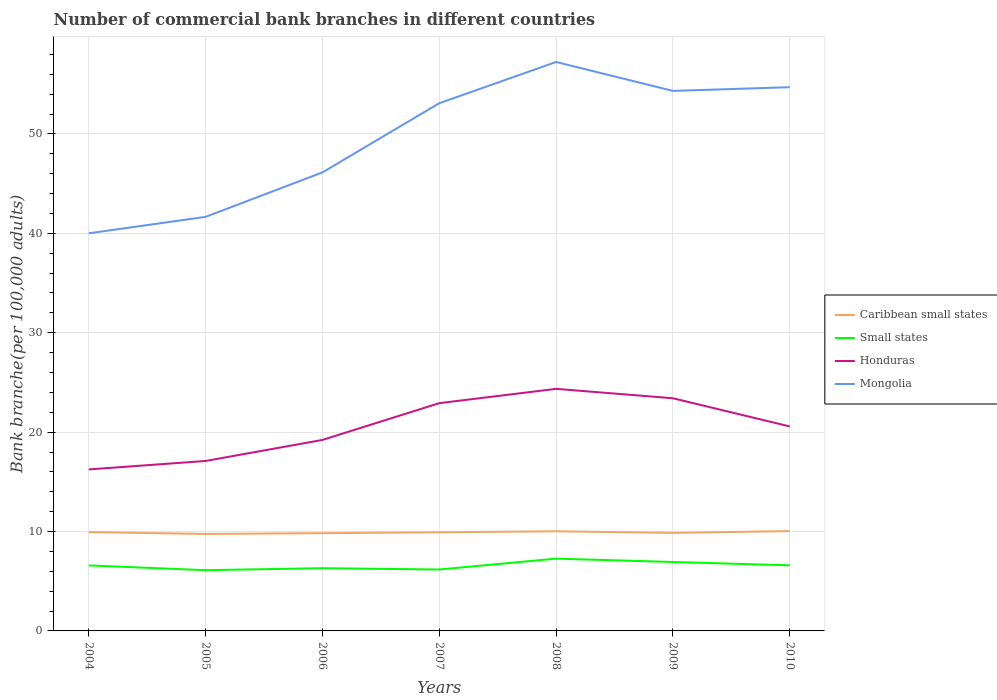How many different coloured lines are there?
Give a very brief answer. 4. Does the line corresponding to Small states intersect with the line corresponding to Caribbean small states?
Provide a short and direct response. No. Across all years, what is the maximum number of commercial bank branches in Mongolia?
Offer a very short reply. 40. What is the total number of commercial bank branches in Small states in the graph?
Your answer should be compact. 0.34. What is the difference between the highest and the second highest number of commercial bank branches in Honduras?
Give a very brief answer. 8.11. How many lines are there?
Keep it short and to the point. 4. Are the values on the major ticks of Y-axis written in scientific E-notation?
Offer a terse response. No. Does the graph contain grids?
Your response must be concise. Yes. Where does the legend appear in the graph?
Provide a short and direct response. Center right. What is the title of the graph?
Ensure brevity in your answer.  Number of commercial bank branches in different countries. What is the label or title of the Y-axis?
Make the answer very short. Bank branche(per 100,0 adults). What is the Bank branche(per 100,000 adults) in Caribbean small states in 2004?
Your response must be concise. 9.95. What is the Bank branche(per 100,000 adults) of Small states in 2004?
Your answer should be compact. 6.59. What is the Bank branche(per 100,000 adults) of Honduras in 2004?
Provide a short and direct response. 16.25. What is the Bank branche(per 100,000 adults) in Mongolia in 2004?
Provide a succinct answer. 40. What is the Bank branche(per 100,000 adults) in Caribbean small states in 2005?
Give a very brief answer. 9.76. What is the Bank branche(per 100,000 adults) in Small states in 2005?
Your answer should be very brief. 6.11. What is the Bank branche(per 100,000 adults) of Honduras in 2005?
Make the answer very short. 17.1. What is the Bank branche(per 100,000 adults) in Mongolia in 2005?
Give a very brief answer. 41.66. What is the Bank branche(per 100,000 adults) of Caribbean small states in 2006?
Make the answer very short. 9.84. What is the Bank branche(per 100,000 adults) in Small states in 2006?
Offer a very short reply. 6.31. What is the Bank branche(per 100,000 adults) in Honduras in 2006?
Your answer should be compact. 19.22. What is the Bank branche(per 100,000 adults) in Mongolia in 2006?
Offer a terse response. 46.13. What is the Bank branche(per 100,000 adults) in Caribbean small states in 2007?
Offer a terse response. 9.92. What is the Bank branche(per 100,000 adults) in Small states in 2007?
Offer a very short reply. 6.18. What is the Bank branche(per 100,000 adults) in Honduras in 2007?
Your answer should be very brief. 22.92. What is the Bank branche(per 100,000 adults) of Mongolia in 2007?
Provide a short and direct response. 53.09. What is the Bank branche(per 100,000 adults) in Caribbean small states in 2008?
Give a very brief answer. 10.02. What is the Bank branche(per 100,000 adults) in Small states in 2008?
Offer a terse response. 7.27. What is the Bank branche(per 100,000 adults) in Honduras in 2008?
Make the answer very short. 24.36. What is the Bank branche(per 100,000 adults) of Mongolia in 2008?
Ensure brevity in your answer.  57.24. What is the Bank branche(per 100,000 adults) of Caribbean small states in 2009?
Your answer should be compact. 9.86. What is the Bank branche(per 100,000 adults) of Small states in 2009?
Ensure brevity in your answer.  6.94. What is the Bank branche(per 100,000 adults) of Honduras in 2009?
Provide a short and direct response. 23.41. What is the Bank branche(per 100,000 adults) in Mongolia in 2009?
Provide a succinct answer. 54.33. What is the Bank branche(per 100,000 adults) of Caribbean small states in 2010?
Give a very brief answer. 10.04. What is the Bank branche(per 100,000 adults) of Small states in 2010?
Offer a very short reply. 6.6. What is the Bank branche(per 100,000 adults) of Honduras in 2010?
Keep it short and to the point. 20.57. What is the Bank branche(per 100,000 adults) of Mongolia in 2010?
Make the answer very short. 54.7. Across all years, what is the maximum Bank branche(per 100,000 adults) in Caribbean small states?
Keep it short and to the point. 10.04. Across all years, what is the maximum Bank branche(per 100,000 adults) of Small states?
Provide a short and direct response. 7.27. Across all years, what is the maximum Bank branche(per 100,000 adults) in Honduras?
Make the answer very short. 24.36. Across all years, what is the maximum Bank branche(per 100,000 adults) of Mongolia?
Make the answer very short. 57.24. Across all years, what is the minimum Bank branche(per 100,000 adults) in Caribbean small states?
Give a very brief answer. 9.76. Across all years, what is the minimum Bank branche(per 100,000 adults) of Small states?
Keep it short and to the point. 6.11. Across all years, what is the minimum Bank branche(per 100,000 adults) of Honduras?
Offer a very short reply. 16.25. Across all years, what is the minimum Bank branche(per 100,000 adults) of Mongolia?
Offer a very short reply. 40. What is the total Bank branche(per 100,000 adults) in Caribbean small states in the graph?
Make the answer very short. 69.39. What is the total Bank branche(per 100,000 adults) in Small states in the graph?
Your response must be concise. 46. What is the total Bank branche(per 100,000 adults) of Honduras in the graph?
Offer a very short reply. 143.81. What is the total Bank branche(per 100,000 adults) of Mongolia in the graph?
Your answer should be compact. 347.16. What is the difference between the Bank branche(per 100,000 adults) of Caribbean small states in 2004 and that in 2005?
Give a very brief answer. 0.19. What is the difference between the Bank branche(per 100,000 adults) in Small states in 2004 and that in 2005?
Provide a succinct answer. 0.48. What is the difference between the Bank branche(per 100,000 adults) in Honduras in 2004 and that in 2005?
Provide a succinct answer. -0.85. What is the difference between the Bank branche(per 100,000 adults) in Mongolia in 2004 and that in 2005?
Offer a terse response. -1.65. What is the difference between the Bank branche(per 100,000 adults) in Caribbean small states in 2004 and that in 2006?
Provide a short and direct response. 0.11. What is the difference between the Bank branche(per 100,000 adults) in Small states in 2004 and that in 2006?
Ensure brevity in your answer.  0.28. What is the difference between the Bank branche(per 100,000 adults) in Honduras in 2004 and that in 2006?
Your response must be concise. -2.97. What is the difference between the Bank branche(per 100,000 adults) of Mongolia in 2004 and that in 2006?
Ensure brevity in your answer.  -6.13. What is the difference between the Bank branche(per 100,000 adults) of Caribbean small states in 2004 and that in 2007?
Ensure brevity in your answer.  0.02. What is the difference between the Bank branche(per 100,000 adults) in Small states in 2004 and that in 2007?
Make the answer very short. 0.41. What is the difference between the Bank branche(per 100,000 adults) of Honduras in 2004 and that in 2007?
Offer a very short reply. -6.67. What is the difference between the Bank branche(per 100,000 adults) in Mongolia in 2004 and that in 2007?
Provide a short and direct response. -13.09. What is the difference between the Bank branche(per 100,000 adults) of Caribbean small states in 2004 and that in 2008?
Your response must be concise. -0.08. What is the difference between the Bank branche(per 100,000 adults) of Small states in 2004 and that in 2008?
Offer a terse response. -0.68. What is the difference between the Bank branche(per 100,000 adults) of Honduras in 2004 and that in 2008?
Keep it short and to the point. -8.11. What is the difference between the Bank branche(per 100,000 adults) of Mongolia in 2004 and that in 2008?
Your answer should be very brief. -17.24. What is the difference between the Bank branche(per 100,000 adults) of Caribbean small states in 2004 and that in 2009?
Your answer should be compact. 0.08. What is the difference between the Bank branche(per 100,000 adults) in Small states in 2004 and that in 2009?
Make the answer very short. -0.35. What is the difference between the Bank branche(per 100,000 adults) in Honduras in 2004 and that in 2009?
Provide a succinct answer. -7.16. What is the difference between the Bank branche(per 100,000 adults) of Mongolia in 2004 and that in 2009?
Your answer should be compact. -14.33. What is the difference between the Bank branche(per 100,000 adults) of Caribbean small states in 2004 and that in 2010?
Keep it short and to the point. -0.1. What is the difference between the Bank branche(per 100,000 adults) of Small states in 2004 and that in 2010?
Your answer should be very brief. -0.01. What is the difference between the Bank branche(per 100,000 adults) of Honduras in 2004 and that in 2010?
Offer a very short reply. -4.33. What is the difference between the Bank branche(per 100,000 adults) of Mongolia in 2004 and that in 2010?
Make the answer very short. -14.7. What is the difference between the Bank branche(per 100,000 adults) in Caribbean small states in 2005 and that in 2006?
Make the answer very short. -0.08. What is the difference between the Bank branche(per 100,000 adults) of Small states in 2005 and that in 2006?
Offer a very short reply. -0.2. What is the difference between the Bank branche(per 100,000 adults) of Honduras in 2005 and that in 2006?
Make the answer very short. -2.12. What is the difference between the Bank branche(per 100,000 adults) of Mongolia in 2005 and that in 2006?
Your answer should be very brief. -4.48. What is the difference between the Bank branche(per 100,000 adults) in Caribbean small states in 2005 and that in 2007?
Ensure brevity in your answer.  -0.16. What is the difference between the Bank branche(per 100,000 adults) in Small states in 2005 and that in 2007?
Provide a succinct answer. -0.07. What is the difference between the Bank branche(per 100,000 adults) in Honduras in 2005 and that in 2007?
Give a very brief answer. -5.82. What is the difference between the Bank branche(per 100,000 adults) in Mongolia in 2005 and that in 2007?
Your response must be concise. -11.43. What is the difference between the Bank branche(per 100,000 adults) in Caribbean small states in 2005 and that in 2008?
Ensure brevity in your answer.  -0.27. What is the difference between the Bank branche(per 100,000 adults) in Small states in 2005 and that in 2008?
Provide a short and direct response. -1.16. What is the difference between the Bank branche(per 100,000 adults) in Honduras in 2005 and that in 2008?
Ensure brevity in your answer.  -7.26. What is the difference between the Bank branche(per 100,000 adults) in Mongolia in 2005 and that in 2008?
Give a very brief answer. -15.58. What is the difference between the Bank branche(per 100,000 adults) of Caribbean small states in 2005 and that in 2009?
Offer a very short reply. -0.11. What is the difference between the Bank branche(per 100,000 adults) in Small states in 2005 and that in 2009?
Offer a terse response. -0.83. What is the difference between the Bank branche(per 100,000 adults) in Honduras in 2005 and that in 2009?
Ensure brevity in your answer.  -6.31. What is the difference between the Bank branche(per 100,000 adults) of Mongolia in 2005 and that in 2009?
Keep it short and to the point. -12.67. What is the difference between the Bank branche(per 100,000 adults) of Caribbean small states in 2005 and that in 2010?
Provide a short and direct response. -0.29. What is the difference between the Bank branche(per 100,000 adults) in Small states in 2005 and that in 2010?
Make the answer very short. -0.49. What is the difference between the Bank branche(per 100,000 adults) of Honduras in 2005 and that in 2010?
Ensure brevity in your answer.  -3.47. What is the difference between the Bank branche(per 100,000 adults) of Mongolia in 2005 and that in 2010?
Your answer should be compact. -13.05. What is the difference between the Bank branche(per 100,000 adults) in Caribbean small states in 2006 and that in 2007?
Make the answer very short. -0.09. What is the difference between the Bank branche(per 100,000 adults) of Small states in 2006 and that in 2007?
Offer a terse response. 0.14. What is the difference between the Bank branche(per 100,000 adults) of Honduras in 2006 and that in 2007?
Your answer should be compact. -3.7. What is the difference between the Bank branche(per 100,000 adults) in Mongolia in 2006 and that in 2007?
Your answer should be very brief. -6.96. What is the difference between the Bank branche(per 100,000 adults) of Caribbean small states in 2006 and that in 2008?
Your response must be concise. -0.19. What is the difference between the Bank branche(per 100,000 adults) in Small states in 2006 and that in 2008?
Ensure brevity in your answer.  -0.96. What is the difference between the Bank branche(per 100,000 adults) of Honduras in 2006 and that in 2008?
Offer a terse response. -5.14. What is the difference between the Bank branche(per 100,000 adults) in Mongolia in 2006 and that in 2008?
Offer a terse response. -11.11. What is the difference between the Bank branche(per 100,000 adults) in Caribbean small states in 2006 and that in 2009?
Your response must be concise. -0.03. What is the difference between the Bank branche(per 100,000 adults) in Small states in 2006 and that in 2009?
Give a very brief answer. -0.62. What is the difference between the Bank branche(per 100,000 adults) of Honduras in 2006 and that in 2009?
Make the answer very short. -4.19. What is the difference between the Bank branche(per 100,000 adults) in Mongolia in 2006 and that in 2009?
Your answer should be very brief. -8.2. What is the difference between the Bank branche(per 100,000 adults) in Caribbean small states in 2006 and that in 2010?
Offer a terse response. -0.21. What is the difference between the Bank branche(per 100,000 adults) in Small states in 2006 and that in 2010?
Offer a terse response. -0.29. What is the difference between the Bank branche(per 100,000 adults) of Honduras in 2006 and that in 2010?
Your answer should be compact. -1.36. What is the difference between the Bank branche(per 100,000 adults) in Mongolia in 2006 and that in 2010?
Make the answer very short. -8.57. What is the difference between the Bank branche(per 100,000 adults) in Caribbean small states in 2007 and that in 2008?
Your answer should be very brief. -0.1. What is the difference between the Bank branche(per 100,000 adults) in Small states in 2007 and that in 2008?
Offer a terse response. -1.1. What is the difference between the Bank branche(per 100,000 adults) in Honduras in 2007 and that in 2008?
Ensure brevity in your answer.  -1.44. What is the difference between the Bank branche(per 100,000 adults) in Mongolia in 2007 and that in 2008?
Provide a short and direct response. -4.15. What is the difference between the Bank branche(per 100,000 adults) of Caribbean small states in 2007 and that in 2009?
Provide a short and direct response. 0.06. What is the difference between the Bank branche(per 100,000 adults) in Small states in 2007 and that in 2009?
Your answer should be compact. -0.76. What is the difference between the Bank branche(per 100,000 adults) in Honduras in 2007 and that in 2009?
Keep it short and to the point. -0.49. What is the difference between the Bank branche(per 100,000 adults) in Mongolia in 2007 and that in 2009?
Offer a very short reply. -1.24. What is the difference between the Bank branche(per 100,000 adults) in Caribbean small states in 2007 and that in 2010?
Your answer should be compact. -0.12. What is the difference between the Bank branche(per 100,000 adults) in Small states in 2007 and that in 2010?
Your answer should be very brief. -0.42. What is the difference between the Bank branche(per 100,000 adults) in Honduras in 2007 and that in 2010?
Your response must be concise. 2.34. What is the difference between the Bank branche(per 100,000 adults) in Mongolia in 2007 and that in 2010?
Keep it short and to the point. -1.61. What is the difference between the Bank branche(per 100,000 adults) of Caribbean small states in 2008 and that in 2009?
Your response must be concise. 0.16. What is the difference between the Bank branche(per 100,000 adults) of Small states in 2008 and that in 2009?
Your response must be concise. 0.34. What is the difference between the Bank branche(per 100,000 adults) in Honduras in 2008 and that in 2009?
Give a very brief answer. 0.95. What is the difference between the Bank branche(per 100,000 adults) in Mongolia in 2008 and that in 2009?
Ensure brevity in your answer.  2.91. What is the difference between the Bank branche(per 100,000 adults) of Caribbean small states in 2008 and that in 2010?
Give a very brief answer. -0.02. What is the difference between the Bank branche(per 100,000 adults) in Small states in 2008 and that in 2010?
Your answer should be very brief. 0.67. What is the difference between the Bank branche(per 100,000 adults) of Honduras in 2008 and that in 2010?
Your response must be concise. 3.78. What is the difference between the Bank branche(per 100,000 adults) of Mongolia in 2008 and that in 2010?
Your answer should be very brief. 2.54. What is the difference between the Bank branche(per 100,000 adults) in Caribbean small states in 2009 and that in 2010?
Ensure brevity in your answer.  -0.18. What is the difference between the Bank branche(per 100,000 adults) in Small states in 2009 and that in 2010?
Offer a terse response. 0.34. What is the difference between the Bank branche(per 100,000 adults) of Honduras in 2009 and that in 2010?
Make the answer very short. 2.83. What is the difference between the Bank branche(per 100,000 adults) in Mongolia in 2009 and that in 2010?
Your response must be concise. -0.37. What is the difference between the Bank branche(per 100,000 adults) of Caribbean small states in 2004 and the Bank branche(per 100,000 adults) of Small states in 2005?
Offer a very short reply. 3.84. What is the difference between the Bank branche(per 100,000 adults) of Caribbean small states in 2004 and the Bank branche(per 100,000 adults) of Honduras in 2005?
Give a very brief answer. -7.15. What is the difference between the Bank branche(per 100,000 adults) of Caribbean small states in 2004 and the Bank branche(per 100,000 adults) of Mongolia in 2005?
Offer a very short reply. -31.71. What is the difference between the Bank branche(per 100,000 adults) in Small states in 2004 and the Bank branche(per 100,000 adults) in Honduras in 2005?
Offer a very short reply. -10.51. What is the difference between the Bank branche(per 100,000 adults) in Small states in 2004 and the Bank branche(per 100,000 adults) in Mongolia in 2005?
Give a very brief answer. -35.07. What is the difference between the Bank branche(per 100,000 adults) in Honduras in 2004 and the Bank branche(per 100,000 adults) in Mongolia in 2005?
Make the answer very short. -25.41. What is the difference between the Bank branche(per 100,000 adults) of Caribbean small states in 2004 and the Bank branche(per 100,000 adults) of Small states in 2006?
Give a very brief answer. 3.63. What is the difference between the Bank branche(per 100,000 adults) of Caribbean small states in 2004 and the Bank branche(per 100,000 adults) of Honduras in 2006?
Make the answer very short. -9.27. What is the difference between the Bank branche(per 100,000 adults) in Caribbean small states in 2004 and the Bank branche(per 100,000 adults) in Mongolia in 2006?
Your response must be concise. -36.19. What is the difference between the Bank branche(per 100,000 adults) in Small states in 2004 and the Bank branche(per 100,000 adults) in Honduras in 2006?
Provide a succinct answer. -12.63. What is the difference between the Bank branche(per 100,000 adults) of Small states in 2004 and the Bank branche(per 100,000 adults) of Mongolia in 2006?
Provide a succinct answer. -39.54. What is the difference between the Bank branche(per 100,000 adults) in Honduras in 2004 and the Bank branche(per 100,000 adults) in Mongolia in 2006?
Provide a succinct answer. -29.89. What is the difference between the Bank branche(per 100,000 adults) of Caribbean small states in 2004 and the Bank branche(per 100,000 adults) of Small states in 2007?
Your response must be concise. 3.77. What is the difference between the Bank branche(per 100,000 adults) in Caribbean small states in 2004 and the Bank branche(per 100,000 adults) in Honduras in 2007?
Keep it short and to the point. -12.97. What is the difference between the Bank branche(per 100,000 adults) in Caribbean small states in 2004 and the Bank branche(per 100,000 adults) in Mongolia in 2007?
Offer a terse response. -43.15. What is the difference between the Bank branche(per 100,000 adults) in Small states in 2004 and the Bank branche(per 100,000 adults) in Honduras in 2007?
Offer a terse response. -16.33. What is the difference between the Bank branche(per 100,000 adults) in Small states in 2004 and the Bank branche(per 100,000 adults) in Mongolia in 2007?
Give a very brief answer. -46.5. What is the difference between the Bank branche(per 100,000 adults) of Honduras in 2004 and the Bank branche(per 100,000 adults) of Mongolia in 2007?
Your answer should be compact. -36.85. What is the difference between the Bank branche(per 100,000 adults) of Caribbean small states in 2004 and the Bank branche(per 100,000 adults) of Small states in 2008?
Make the answer very short. 2.67. What is the difference between the Bank branche(per 100,000 adults) of Caribbean small states in 2004 and the Bank branche(per 100,000 adults) of Honduras in 2008?
Offer a very short reply. -14.41. What is the difference between the Bank branche(per 100,000 adults) in Caribbean small states in 2004 and the Bank branche(per 100,000 adults) in Mongolia in 2008?
Provide a succinct answer. -47.29. What is the difference between the Bank branche(per 100,000 adults) in Small states in 2004 and the Bank branche(per 100,000 adults) in Honduras in 2008?
Offer a very short reply. -17.77. What is the difference between the Bank branche(per 100,000 adults) in Small states in 2004 and the Bank branche(per 100,000 adults) in Mongolia in 2008?
Your response must be concise. -50.65. What is the difference between the Bank branche(per 100,000 adults) in Honduras in 2004 and the Bank branche(per 100,000 adults) in Mongolia in 2008?
Provide a succinct answer. -40.99. What is the difference between the Bank branche(per 100,000 adults) of Caribbean small states in 2004 and the Bank branche(per 100,000 adults) of Small states in 2009?
Your response must be concise. 3.01. What is the difference between the Bank branche(per 100,000 adults) of Caribbean small states in 2004 and the Bank branche(per 100,000 adults) of Honduras in 2009?
Provide a short and direct response. -13.46. What is the difference between the Bank branche(per 100,000 adults) of Caribbean small states in 2004 and the Bank branche(per 100,000 adults) of Mongolia in 2009?
Your answer should be very brief. -44.38. What is the difference between the Bank branche(per 100,000 adults) of Small states in 2004 and the Bank branche(per 100,000 adults) of Honduras in 2009?
Provide a succinct answer. -16.82. What is the difference between the Bank branche(per 100,000 adults) of Small states in 2004 and the Bank branche(per 100,000 adults) of Mongolia in 2009?
Ensure brevity in your answer.  -47.74. What is the difference between the Bank branche(per 100,000 adults) in Honduras in 2004 and the Bank branche(per 100,000 adults) in Mongolia in 2009?
Provide a short and direct response. -38.08. What is the difference between the Bank branche(per 100,000 adults) in Caribbean small states in 2004 and the Bank branche(per 100,000 adults) in Small states in 2010?
Your answer should be compact. 3.35. What is the difference between the Bank branche(per 100,000 adults) of Caribbean small states in 2004 and the Bank branche(per 100,000 adults) of Honduras in 2010?
Provide a short and direct response. -10.63. What is the difference between the Bank branche(per 100,000 adults) in Caribbean small states in 2004 and the Bank branche(per 100,000 adults) in Mongolia in 2010?
Offer a terse response. -44.76. What is the difference between the Bank branche(per 100,000 adults) of Small states in 2004 and the Bank branche(per 100,000 adults) of Honduras in 2010?
Provide a short and direct response. -13.98. What is the difference between the Bank branche(per 100,000 adults) of Small states in 2004 and the Bank branche(per 100,000 adults) of Mongolia in 2010?
Make the answer very short. -48.11. What is the difference between the Bank branche(per 100,000 adults) of Honduras in 2004 and the Bank branche(per 100,000 adults) of Mongolia in 2010?
Make the answer very short. -38.46. What is the difference between the Bank branche(per 100,000 adults) in Caribbean small states in 2005 and the Bank branche(per 100,000 adults) in Small states in 2006?
Offer a terse response. 3.45. What is the difference between the Bank branche(per 100,000 adults) of Caribbean small states in 2005 and the Bank branche(per 100,000 adults) of Honduras in 2006?
Your answer should be very brief. -9.46. What is the difference between the Bank branche(per 100,000 adults) in Caribbean small states in 2005 and the Bank branche(per 100,000 adults) in Mongolia in 2006?
Provide a succinct answer. -36.38. What is the difference between the Bank branche(per 100,000 adults) in Small states in 2005 and the Bank branche(per 100,000 adults) in Honduras in 2006?
Keep it short and to the point. -13.11. What is the difference between the Bank branche(per 100,000 adults) in Small states in 2005 and the Bank branche(per 100,000 adults) in Mongolia in 2006?
Provide a succinct answer. -40.02. What is the difference between the Bank branche(per 100,000 adults) in Honduras in 2005 and the Bank branche(per 100,000 adults) in Mongolia in 2006?
Your answer should be very brief. -29.03. What is the difference between the Bank branche(per 100,000 adults) of Caribbean small states in 2005 and the Bank branche(per 100,000 adults) of Small states in 2007?
Offer a terse response. 3.58. What is the difference between the Bank branche(per 100,000 adults) in Caribbean small states in 2005 and the Bank branche(per 100,000 adults) in Honduras in 2007?
Your answer should be very brief. -13.16. What is the difference between the Bank branche(per 100,000 adults) in Caribbean small states in 2005 and the Bank branche(per 100,000 adults) in Mongolia in 2007?
Keep it short and to the point. -43.33. What is the difference between the Bank branche(per 100,000 adults) of Small states in 2005 and the Bank branche(per 100,000 adults) of Honduras in 2007?
Ensure brevity in your answer.  -16.81. What is the difference between the Bank branche(per 100,000 adults) in Small states in 2005 and the Bank branche(per 100,000 adults) in Mongolia in 2007?
Offer a terse response. -46.98. What is the difference between the Bank branche(per 100,000 adults) of Honduras in 2005 and the Bank branche(per 100,000 adults) of Mongolia in 2007?
Keep it short and to the point. -35.99. What is the difference between the Bank branche(per 100,000 adults) in Caribbean small states in 2005 and the Bank branche(per 100,000 adults) in Small states in 2008?
Keep it short and to the point. 2.49. What is the difference between the Bank branche(per 100,000 adults) in Caribbean small states in 2005 and the Bank branche(per 100,000 adults) in Honduras in 2008?
Keep it short and to the point. -14.6. What is the difference between the Bank branche(per 100,000 adults) of Caribbean small states in 2005 and the Bank branche(per 100,000 adults) of Mongolia in 2008?
Make the answer very short. -47.48. What is the difference between the Bank branche(per 100,000 adults) in Small states in 2005 and the Bank branche(per 100,000 adults) in Honduras in 2008?
Offer a very short reply. -18.25. What is the difference between the Bank branche(per 100,000 adults) of Small states in 2005 and the Bank branche(per 100,000 adults) of Mongolia in 2008?
Offer a terse response. -51.13. What is the difference between the Bank branche(per 100,000 adults) in Honduras in 2005 and the Bank branche(per 100,000 adults) in Mongolia in 2008?
Give a very brief answer. -40.14. What is the difference between the Bank branche(per 100,000 adults) in Caribbean small states in 2005 and the Bank branche(per 100,000 adults) in Small states in 2009?
Provide a short and direct response. 2.82. What is the difference between the Bank branche(per 100,000 adults) in Caribbean small states in 2005 and the Bank branche(per 100,000 adults) in Honduras in 2009?
Offer a terse response. -13.65. What is the difference between the Bank branche(per 100,000 adults) of Caribbean small states in 2005 and the Bank branche(per 100,000 adults) of Mongolia in 2009?
Give a very brief answer. -44.57. What is the difference between the Bank branche(per 100,000 adults) in Small states in 2005 and the Bank branche(per 100,000 adults) in Honduras in 2009?
Provide a short and direct response. -17.3. What is the difference between the Bank branche(per 100,000 adults) of Small states in 2005 and the Bank branche(per 100,000 adults) of Mongolia in 2009?
Provide a succinct answer. -48.22. What is the difference between the Bank branche(per 100,000 adults) in Honduras in 2005 and the Bank branche(per 100,000 adults) in Mongolia in 2009?
Offer a terse response. -37.23. What is the difference between the Bank branche(per 100,000 adults) of Caribbean small states in 2005 and the Bank branche(per 100,000 adults) of Small states in 2010?
Make the answer very short. 3.16. What is the difference between the Bank branche(per 100,000 adults) in Caribbean small states in 2005 and the Bank branche(per 100,000 adults) in Honduras in 2010?
Make the answer very short. -10.82. What is the difference between the Bank branche(per 100,000 adults) in Caribbean small states in 2005 and the Bank branche(per 100,000 adults) in Mongolia in 2010?
Provide a succinct answer. -44.95. What is the difference between the Bank branche(per 100,000 adults) of Small states in 2005 and the Bank branche(per 100,000 adults) of Honduras in 2010?
Provide a succinct answer. -14.46. What is the difference between the Bank branche(per 100,000 adults) in Small states in 2005 and the Bank branche(per 100,000 adults) in Mongolia in 2010?
Make the answer very short. -48.59. What is the difference between the Bank branche(per 100,000 adults) in Honduras in 2005 and the Bank branche(per 100,000 adults) in Mongolia in 2010?
Give a very brief answer. -37.6. What is the difference between the Bank branche(per 100,000 adults) of Caribbean small states in 2006 and the Bank branche(per 100,000 adults) of Small states in 2007?
Provide a succinct answer. 3.66. What is the difference between the Bank branche(per 100,000 adults) of Caribbean small states in 2006 and the Bank branche(per 100,000 adults) of Honduras in 2007?
Make the answer very short. -13.08. What is the difference between the Bank branche(per 100,000 adults) in Caribbean small states in 2006 and the Bank branche(per 100,000 adults) in Mongolia in 2007?
Your response must be concise. -43.26. What is the difference between the Bank branche(per 100,000 adults) in Small states in 2006 and the Bank branche(per 100,000 adults) in Honduras in 2007?
Keep it short and to the point. -16.6. What is the difference between the Bank branche(per 100,000 adults) of Small states in 2006 and the Bank branche(per 100,000 adults) of Mongolia in 2007?
Give a very brief answer. -46.78. What is the difference between the Bank branche(per 100,000 adults) of Honduras in 2006 and the Bank branche(per 100,000 adults) of Mongolia in 2007?
Your response must be concise. -33.88. What is the difference between the Bank branche(per 100,000 adults) in Caribbean small states in 2006 and the Bank branche(per 100,000 adults) in Small states in 2008?
Keep it short and to the point. 2.56. What is the difference between the Bank branche(per 100,000 adults) in Caribbean small states in 2006 and the Bank branche(per 100,000 adults) in Honduras in 2008?
Offer a terse response. -14.52. What is the difference between the Bank branche(per 100,000 adults) in Caribbean small states in 2006 and the Bank branche(per 100,000 adults) in Mongolia in 2008?
Provide a succinct answer. -47.4. What is the difference between the Bank branche(per 100,000 adults) of Small states in 2006 and the Bank branche(per 100,000 adults) of Honduras in 2008?
Make the answer very short. -18.04. What is the difference between the Bank branche(per 100,000 adults) in Small states in 2006 and the Bank branche(per 100,000 adults) in Mongolia in 2008?
Provide a short and direct response. -50.93. What is the difference between the Bank branche(per 100,000 adults) in Honduras in 2006 and the Bank branche(per 100,000 adults) in Mongolia in 2008?
Offer a terse response. -38.02. What is the difference between the Bank branche(per 100,000 adults) in Caribbean small states in 2006 and the Bank branche(per 100,000 adults) in Small states in 2009?
Provide a succinct answer. 2.9. What is the difference between the Bank branche(per 100,000 adults) of Caribbean small states in 2006 and the Bank branche(per 100,000 adults) of Honduras in 2009?
Your answer should be compact. -13.57. What is the difference between the Bank branche(per 100,000 adults) of Caribbean small states in 2006 and the Bank branche(per 100,000 adults) of Mongolia in 2009?
Give a very brief answer. -44.49. What is the difference between the Bank branche(per 100,000 adults) in Small states in 2006 and the Bank branche(per 100,000 adults) in Honduras in 2009?
Your answer should be compact. -17.1. What is the difference between the Bank branche(per 100,000 adults) in Small states in 2006 and the Bank branche(per 100,000 adults) in Mongolia in 2009?
Your answer should be very brief. -48.02. What is the difference between the Bank branche(per 100,000 adults) of Honduras in 2006 and the Bank branche(per 100,000 adults) of Mongolia in 2009?
Provide a short and direct response. -35.11. What is the difference between the Bank branche(per 100,000 adults) of Caribbean small states in 2006 and the Bank branche(per 100,000 adults) of Small states in 2010?
Provide a succinct answer. 3.24. What is the difference between the Bank branche(per 100,000 adults) in Caribbean small states in 2006 and the Bank branche(per 100,000 adults) in Honduras in 2010?
Provide a short and direct response. -10.74. What is the difference between the Bank branche(per 100,000 adults) of Caribbean small states in 2006 and the Bank branche(per 100,000 adults) of Mongolia in 2010?
Offer a terse response. -44.87. What is the difference between the Bank branche(per 100,000 adults) in Small states in 2006 and the Bank branche(per 100,000 adults) in Honduras in 2010?
Ensure brevity in your answer.  -14.26. What is the difference between the Bank branche(per 100,000 adults) in Small states in 2006 and the Bank branche(per 100,000 adults) in Mongolia in 2010?
Offer a terse response. -48.39. What is the difference between the Bank branche(per 100,000 adults) in Honduras in 2006 and the Bank branche(per 100,000 adults) in Mongolia in 2010?
Provide a succinct answer. -35.49. What is the difference between the Bank branche(per 100,000 adults) in Caribbean small states in 2007 and the Bank branche(per 100,000 adults) in Small states in 2008?
Your response must be concise. 2.65. What is the difference between the Bank branche(per 100,000 adults) in Caribbean small states in 2007 and the Bank branche(per 100,000 adults) in Honduras in 2008?
Your answer should be very brief. -14.43. What is the difference between the Bank branche(per 100,000 adults) of Caribbean small states in 2007 and the Bank branche(per 100,000 adults) of Mongolia in 2008?
Ensure brevity in your answer.  -47.32. What is the difference between the Bank branche(per 100,000 adults) in Small states in 2007 and the Bank branche(per 100,000 adults) in Honduras in 2008?
Offer a very short reply. -18.18. What is the difference between the Bank branche(per 100,000 adults) of Small states in 2007 and the Bank branche(per 100,000 adults) of Mongolia in 2008?
Your answer should be compact. -51.06. What is the difference between the Bank branche(per 100,000 adults) in Honduras in 2007 and the Bank branche(per 100,000 adults) in Mongolia in 2008?
Provide a short and direct response. -34.32. What is the difference between the Bank branche(per 100,000 adults) of Caribbean small states in 2007 and the Bank branche(per 100,000 adults) of Small states in 2009?
Provide a succinct answer. 2.99. What is the difference between the Bank branche(per 100,000 adults) in Caribbean small states in 2007 and the Bank branche(per 100,000 adults) in Honduras in 2009?
Give a very brief answer. -13.49. What is the difference between the Bank branche(per 100,000 adults) in Caribbean small states in 2007 and the Bank branche(per 100,000 adults) in Mongolia in 2009?
Provide a short and direct response. -44.41. What is the difference between the Bank branche(per 100,000 adults) in Small states in 2007 and the Bank branche(per 100,000 adults) in Honduras in 2009?
Give a very brief answer. -17.23. What is the difference between the Bank branche(per 100,000 adults) in Small states in 2007 and the Bank branche(per 100,000 adults) in Mongolia in 2009?
Provide a succinct answer. -48.15. What is the difference between the Bank branche(per 100,000 adults) of Honduras in 2007 and the Bank branche(per 100,000 adults) of Mongolia in 2009?
Your answer should be very brief. -31.41. What is the difference between the Bank branche(per 100,000 adults) in Caribbean small states in 2007 and the Bank branche(per 100,000 adults) in Small states in 2010?
Provide a succinct answer. 3.32. What is the difference between the Bank branche(per 100,000 adults) in Caribbean small states in 2007 and the Bank branche(per 100,000 adults) in Honduras in 2010?
Ensure brevity in your answer.  -10.65. What is the difference between the Bank branche(per 100,000 adults) in Caribbean small states in 2007 and the Bank branche(per 100,000 adults) in Mongolia in 2010?
Provide a succinct answer. -44.78. What is the difference between the Bank branche(per 100,000 adults) in Small states in 2007 and the Bank branche(per 100,000 adults) in Honduras in 2010?
Give a very brief answer. -14.4. What is the difference between the Bank branche(per 100,000 adults) of Small states in 2007 and the Bank branche(per 100,000 adults) of Mongolia in 2010?
Your answer should be very brief. -48.53. What is the difference between the Bank branche(per 100,000 adults) in Honduras in 2007 and the Bank branche(per 100,000 adults) in Mongolia in 2010?
Offer a very short reply. -31.79. What is the difference between the Bank branche(per 100,000 adults) of Caribbean small states in 2008 and the Bank branche(per 100,000 adults) of Small states in 2009?
Offer a very short reply. 3.09. What is the difference between the Bank branche(per 100,000 adults) of Caribbean small states in 2008 and the Bank branche(per 100,000 adults) of Honduras in 2009?
Your answer should be compact. -13.38. What is the difference between the Bank branche(per 100,000 adults) of Caribbean small states in 2008 and the Bank branche(per 100,000 adults) of Mongolia in 2009?
Make the answer very short. -44.31. What is the difference between the Bank branche(per 100,000 adults) of Small states in 2008 and the Bank branche(per 100,000 adults) of Honduras in 2009?
Your answer should be very brief. -16.14. What is the difference between the Bank branche(per 100,000 adults) in Small states in 2008 and the Bank branche(per 100,000 adults) in Mongolia in 2009?
Ensure brevity in your answer.  -47.06. What is the difference between the Bank branche(per 100,000 adults) of Honduras in 2008 and the Bank branche(per 100,000 adults) of Mongolia in 2009?
Provide a short and direct response. -29.97. What is the difference between the Bank branche(per 100,000 adults) of Caribbean small states in 2008 and the Bank branche(per 100,000 adults) of Small states in 2010?
Make the answer very short. 3.43. What is the difference between the Bank branche(per 100,000 adults) in Caribbean small states in 2008 and the Bank branche(per 100,000 adults) in Honduras in 2010?
Your answer should be compact. -10.55. What is the difference between the Bank branche(per 100,000 adults) of Caribbean small states in 2008 and the Bank branche(per 100,000 adults) of Mongolia in 2010?
Ensure brevity in your answer.  -44.68. What is the difference between the Bank branche(per 100,000 adults) of Small states in 2008 and the Bank branche(per 100,000 adults) of Honduras in 2010?
Your answer should be compact. -13.3. What is the difference between the Bank branche(per 100,000 adults) of Small states in 2008 and the Bank branche(per 100,000 adults) of Mongolia in 2010?
Provide a succinct answer. -47.43. What is the difference between the Bank branche(per 100,000 adults) in Honduras in 2008 and the Bank branche(per 100,000 adults) in Mongolia in 2010?
Your answer should be very brief. -30.35. What is the difference between the Bank branche(per 100,000 adults) in Caribbean small states in 2009 and the Bank branche(per 100,000 adults) in Small states in 2010?
Give a very brief answer. 3.27. What is the difference between the Bank branche(per 100,000 adults) of Caribbean small states in 2009 and the Bank branche(per 100,000 adults) of Honduras in 2010?
Your answer should be very brief. -10.71. What is the difference between the Bank branche(per 100,000 adults) of Caribbean small states in 2009 and the Bank branche(per 100,000 adults) of Mongolia in 2010?
Your answer should be compact. -44.84. What is the difference between the Bank branche(per 100,000 adults) in Small states in 2009 and the Bank branche(per 100,000 adults) in Honduras in 2010?
Make the answer very short. -13.64. What is the difference between the Bank branche(per 100,000 adults) in Small states in 2009 and the Bank branche(per 100,000 adults) in Mongolia in 2010?
Your answer should be compact. -47.77. What is the difference between the Bank branche(per 100,000 adults) in Honduras in 2009 and the Bank branche(per 100,000 adults) in Mongolia in 2010?
Offer a very short reply. -31.3. What is the average Bank branche(per 100,000 adults) in Caribbean small states per year?
Offer a very short reply. 9.91. What is the average Bank branche(per 100,000 adults) in Small states per year?
Give a very brief answer. 6.57. What is the average Bank branche(per 100,000 adults) of Honduras per year?
Ensure brevity in your answer.  20.54. What is the average Bank branche(per 100,000 adults) of Mongolia per year?
Provide a succinct answer. 49.59. In the year 2004, what is the difference between the Bank branche(per 100,000 adults) in Caribbean small states and Bank branche(per 100,000 adults) in Small states?
Provide a succinct answer. 3.36. In the year 2004, what is the difference between the Bank branche(per 100,000 adults) of Caribbean small states and Bank branche(per 100,000 adults) of Honduras?
Keep it short and to the point. -6.3. In the year 2004, what is the difference between the Bank branche(per 100,000 adults) of Caribbean small states and Bank branche(per 100,000 adults) of Mongolia?
Offer a terse response. -30.06. In the year 2004, what is the difference between the Bank branche(per 100,000 adults) of Small states and Bank branche(per 100,000 adults) of Honduras?
Offer a terse response. -9.66. In the year 2004, what is the difference between the Bank branche(per 100,000 adults) of Small states and Bank branche(per 100,000 adults) of Mongolia?
Offer a terse response. -33.41. In the year 2004, what is the difference between the Bank branche(per 100,000 adults) of Honduras and Bank branche(per 100,000 adults) of Mongolia?
Give a very brief answer. -23.76. In the year 2005, what is the difference between the Bank branche(per 100,000 adults) in Caribbean small states and Bank branche(per 100,000 adults) in Small states?
Your response must be concise. 3.65. In the year 2005, what is the difference between the Bank branche(per 100,000 adults) of Caribbean small states and Bank branche(per 100,000 adults) of Honduras?
Your answer should be very brief. -7.34. In the year 2005, what is the difference between the Bank branche(per 100,000 adults) of Caribbean small states and Bank branche(per 100,000 adults) of Mongolia?
Keep it short and to the point. -31.9. In the year 2005, what is the difference between the Bank branche(per 100,000 adults) of Small states and Bank branche(per 100,000 adults) of Honduras?
Your response must be concise. -10.99. In the year 2005, what is the difference between the Bank branche(per 100,000 adults) of Small states and Bank branche(per 100,000 adults) of Mongolia?
Keep it short and to the point. -35.55. In the year 2005, what is the difference between the Bank branche(per 100,000 adults) in Honduras and Bank branche(per 100,000 adults) in Mongolia?
Keep it short and to the point. -24.56. In the year 2006, what is the difference between the Bank branche(per 100,000 adults) of Caribbean small states and Bank branche(per 100,000 adults) of Small states?
Give a very brief answer. 3.52. In the year 2006, what is the difference between the Bank branche(per 100,000 adults) in Caribbean small states and Bank branche(per 100,000 adults) in Honduras?
Provide a short and direct response. -9.38. In the year 2006, what is the difference between the Bank branche(per 100,000 adults) of Caribbean small states and Bank branche(per 100,000 adults) of Mongolia?
Provide a short and direct response. -36.3. In the year 2006, what is the difference between the Bank branche(per 100,000 adults) in Small states and Bank branche(per 100,000 adults) in Honduras?
Your response must be concise. -12.9. In the year 2006, what is the difference between the Bank branche(per 100,000 adults) in Small states and Bank branche(per 100,000 adults) in Mongolia?
Your answer should be very brief. -39.82. In the year 2006, what is the difference between the Bank branche(per 100,000 adults) of Honduras and Bank branche(per 100,000 adults) of Mongolia?
Offer a very short reply. -26.92. In the year 2007, what is the difference between the Bank branche(per 100,000 adults) in Caribbean small states and Bank branche(per 100,000 adults) in Small states?
Keep it short and to the point. 3.75. In the year 2007, what is the difference between the Bank branche(per 100,000 adults) of Caribbean small states and Bank branche(per 100,000 adults) of Honduras?
Offer a very short reply. -12.99. In the year 2007, what is the difference between the Bank branche(per 100,000 adults) of Caribbean small states and Bank branche(per 100,000 adults) of Mongolia?
Your answer should be compact. -43.17. In the year 2007, what is the difference between the Bank branche(per 100,000 adults) in Small states and Bank branche(per 100,000 adults) in Honduras?
Offer a terse response. -16.74. In the year 2007, what is the difference between the Bank branche(per 100,000 adults) in Small states and Bank branche(per 100,000 adults) in Mongolia?
Provide a succinct answer. -46.92. In the year 2007, what is the difference between the Bank branche(per 100,000 adults) of Honduras and Bank branche(per 100,000 adults) of Mongolia?
Provide a short and direct response. -30.18. In the year 2008, what is the difference between the Bank branche(per 100,000 adults) of Caribbean small states and Bank branche(per 100,000 adults) of Small states?
Offer a terse response. 2.75. In the year 2008, what is the difference between the Bank branche(per 100,000 adults) of Caribbean small states and Bank branche(per 100,000 adults) of Honduras?
Offer a very short reply. -14.33. In the year 2008, what is the difference between the Bank branche(per 100,000 adults) in Caribbean small states and Bank branche(per 100,000 adults) in Mongolia?
Your response must be concise. -47.22. In the year 2008, what is the difference between the Bank branche(per 100,000 adults) of Small states and Bank branche(per 100,000 adults) of Honduras?
Your response must be concise. -17.08. In the year 2008, what is the difference between the Bank branche(per 100,000 adults) in Small states and Bank branche(per 100,000 adults) in Mongolia?
Keep it short and to the point. -49.97. In the year 2008, what is the difference between the Bank branche(per 100,000 adults) of Honduras and Bank branche(per 100,000 adults) of Mongolia?
Ensure brevity in your answer.  -32.89. In the year 2009, what is the difference between the Bank branche(per 100,000 adults) in Caribbean small states and Bank branche(per 100,000 adults) in Small states?
Give a very brief answer. 2.93. In the year 2009, what is the difference between the Bank branche(per 100,000 adults) in Caribbean small states and Bank branche(per 100,000 adults) in Honduras?
Offer a terse response. -13.54. In the year 2009, what is the difference between the Bank branche(per 100,000 adults) in Caribbean small states and Bank branche(per 100,000 adults) in Mongolia?
Keep it short and to the point. -44.47. In the year 2009, what is the difference between the Bank branche(per 100,000 adults) of Small states and Bank branche(per 100,000 adults) of Honduras?
Offer a very short reply. -16.47. In the year 2009, what is the difference between the Bank branche(per 100,000 adults) in Small states and Bank branche(per 100,000 adults) in Mongolia?
Ensure brevity in your answer.  -47.39. In the year 2009, what is the difference between the Bank branche(per 100,000 adults) of Honduras and Bank branche(per 100,000 adults) of Mongolia?
Your response must be concise. -30.92. In the year 2010, what is the difference between the Bank branche(per 100,000 adults) of Caribbean small states and Bank branche(per 100,000 adults) of Small states?
Your response must be concise. 3.44. In the year 2010, what is the difference between the Bank branche(per 100,000 adults) in Caribbean small states and Bank branche(per 100,000 adults) in Honduras?
Your answer should be very brief. -10.53. In the year 2010, what is the difference between the Bank branche(per 100,000 adults) of Caribbean small states and Bank branche(per 100,000 adults) of Mongolia?
Offer a very short reply. -44.66. In the year 2010, what is the difference between the Bank branche(per 100,000 adults) in Small states and Bank branche(per 100,000 adults) in Honduras?
Your answer should be compact. -13.97. In the year 2010, what is the difference between the Bank branche(per 100,000 adults) of Small states and Bank branche(per 100,000 adults) of Mongolia?
Give a very brief answer. -48.11. In the year 2010, what is the difference between the Bank branche(per 100,000 adults) in Honduras and Bank branche(per 100,000 adults) in Mongolia?
Give a very brief answer. -34.13. What is the ratio of the Bank branche(per 100,000 adults) of Caribbean small states in 2004 to that in 2005?
Offer a terse response. 1.02. What is the ratio of the Bank branche(per 100,000 adults) in Small states in 2004 to that in 2005?
Provide a short and direct response. 1.08. What is the ratio of the Bank branche(per 100,000 adults) in Honduras in 2004 to that in 2005?
Ensure brevity in your answer.  0.95. What is the ratio of the Bank branche(per 100,000 adults) of Mongolia in 2004 to that in 2005?
Your answer should be compact. 0.96. What is the ratio of the Bank branche(per 100,000 adults) of Caribbean small states in 2004 to that in 2006?
Offer a terse response. 1.01. What is the ratio of the Bank branche(per 100,000 adults) of Small states in 2004 to that in 2006?
Offer a very short reply. 1.04. What is the ratio of the Bank branche(per 100,000 adults) of Honduras in 2004 to that in 2006?
Offer a terse response. 0.85. What is the ratio of the Bank branche(per 100,000 adults) in Mongolia in 2004 to that in 2006?
Your response must be concise. 0.87. What is the ratio of the Bank branche(per 100,000 adults) of Caribbean small states in 2004 to that in 2007?
Offer a terse response. 1. What is the ratio of the Bank branche(per 100,000 adults) in Small states in 2004 to that in 2007?
Keep it short and to the point. 1.07. What is the ratio of the Bank branche(per 100,000 adults) in Honduras in 2004 to that in 2007?
Your answer should be compact. 0.71. What is the ratio of the Bank branche(per 100,000 adults) in Mongolia in 2004 to that in 2007?
Provide a succinct answer. 0.75. What is the ratio of the Bank branche(per 100,000 adults) of Caribbean small states in 2004 to that in 2008?
Keep it short and to the point. 0.99. What is the ratio of the Bank branche(per 100,000 adults) of Small states in 2004 to that in 2008?
Provide a short and direct response. 0.91. What is the ratio of the Bank branche(per 100,000 adults) of Honduras in 2004 to that in 2008?
Offer a terse response. 0.67. What is the ratio of the Bank branche(per 100,000 adults) of Mongolia in 2004 to that in 2008?
Provide a succinct answer. 0.7. What is the ratio of the Bank branche(per 100,000 adults) of Caribbean small states in 2004 to that in 2009?
Provide a short and direct response. 1.01. What is the ratio of the Bank branche(per 100,000 adults) of Small states in 2004 to that in 2009?
Offer a terse response. 0.95. What is the ratio of the Bank branche(per 100,000 adults) in Honduras in 2004 to that in 2009?
Ensure brevity in your answer.  0.69. What is the ratio of the Bank branche(per 100,000 adults) of Mongolia in 2004 to that in 2009?
Offer a very short reply. 0.74. What is the ratio of the Bank branche(per 100,000 adults) of Caribbean small states in 2004 to that in 2010?
Offer a terse response. 0.99. What is the ratio of the Bank branche(per 100,000 adults) of Honduras in 2004 to that in 2010?
Your answer should be very brief. 0.79. What is the ratio of the Bank branche(per 100,000 adults) in Mongolia in 2004 to that in 2010?
Offer a very short reply. 0.73. What is the ratio of the Bank branche(per 100,000 adults) of Caribbean small states in 2005 to that in 2006?
Your response must be concise. 0.99. What is the ratio of the Bank branche(per 100,000 adults) of Honduras in 2005 to that in 2006?
Offer a terse response. 0.89. What is the ratio of the Bank branche(per 100,000 adults) in Mongolia in 2005 to that in 2006?
Ensure brevity in your answer.  0.9. What is the ratio of the Bank branche(per 100,000 adults) of Caribbean small states in 2005 to that in 2007?
Your answer should be very brief. 0.98. What is the ratio of the Bank branche(per 100,000 adults) of Honduras in 2005 to that in 2007?
Your response must be concise. 0.75. What is the ratio of the Bank branche(per 100,000 adults) in Mongolia in 2005 to that in 2007?
Your answer should be compact. 0.78. What is the ratio of the Bank branche(per 100,000 adults) in Caribbean small states in 2005 to that in 2008?
Ensure brevity in your answer.  0.97. What is the ratio of the Bank branche(per 100,000 adults) in Small states in 2005 to that in 2008?
Give a very brief answer. 0.84. What is the ratio of the Bank branche(per 100,000 adults) of Honduras in 2005 to that in 2008?
Provide a succinct answer. 0.7. What is the ratio of the Bank branche(per 100,000 adults) in Mongolia in 2005 to that in 2008?
Your answer should be compact. 0.73. What is the ratio of the Bank branche(per 100,000 adults) in Small states in 2005 to that in 2009?
Provide a succinct answer. 0.88. What is the ratio of the Bank branche(per 100,000 adults) in Honduras in 2005 to that in 2009?
Give a very brief answer. 0.73. What is the ratio of the Bank branche(per 100,000 adults) of Mongolia in 2005 to that in 2009?
Your response must be concise. 0.77. What is the ratio of the Bank branche(per 100,000 adults) of Caribbean small states in 2005 to that in 2010?
Provide a succinct answer. 0.97. What is the ratio of the Bank branche(per 100,000 adults) of Small states in 2005 to that in 2010?
Keep it short and to the point. 0.93. What is the ratio of the Bank branche(per 100,000 adults) of Honduras in 2005 to that in 2010?
Keep it short and to the point. 0.83. What is the ratio of the Bank branche(per 100,000 adults) of Mongolia in 2005 to that in 2010?
Give a very brief answer. 0.76. What is the ratio of the Bank branche(per 100,000 adults) in Caribbean small states in 2006 to that in 2007?
Offer a terse response. 0.99. What is the ratio of the Bank branche(per 100,000 adults) of Small states in 2006 to that in 2007?
Your answer should be compact. 1.02. What is the ratio of the Bank branche(per 100,000 adults) of Honduras in 2006 to that in 2007?
Offer a very short reply. 0.84. What is the ratio of the Bank branche(per 100,000 adults) in Mongolia in 2006 to that in 2007?
Offer a terse response. 0.87. What is the ratio of the Bank branche(per 100,000 adults) in Caribbean small states in 2006 to that in 2008?
Provide a succinct answer. 0.98. What is the ratio of the Bank branche(per 100,000 adults) of Small states in 2006 to that in 2008?
Your response must be concise. 0.87. What is the ratio of the Bank branche(per 100,000 adults) in Honduras in 2006 to that in 2008?
Your answer should be very brief. 0.79. What is the ratio of the Bank branche(per 100,000 adults) of Mongolia in 2006 to that in 2008?
Offer a terse response. 0.81. What is the ratio of the Bank branche(per 100,000 adults) in Caribbean small states in 2006 to that in 2009?
Give a very brief answer. 1. What is the ratio of the Bank branche(per 100,000 adults) in Small states in 2006 to that in 2009?
Provide a succinct answer. 0.91. What is the ratio of the Bank branche(per 100,000 adults) in Honduras in 2006 to that in 2009?
Your answer should be very brief. 0.82. What is the ratio of the Bank branche(per 100,000 adults) in Mongolia in 2006 to that in 2009?
Offer a terse response. 0.85. What is the ratio of the Bank branche(per 100,000 adults) of Caribbean small states in 2006 to that in 2010?
Your response must be concise. 0.98. What is the ratio of the Bank branche(per 100,000 adults) in Small states in 2006 to that in 2010?
Provide a succinct answer. 0.96. What is the ratio of the Bank branche(per 100,000 adults) of Honduras in 2006 to that in 2010?
Offer a terse response. 0.93. What is the ratio of the Bank branche(per 100,000 adults) of Mongolia in 2006 to that in 2010?
Your response must be concise. 0.84. What is the ratio of the Bank branche(per 100,000 adults) of Small states in 2007 to that in 2008?
Give a very brief answer. 0.85. What is the ratio of the Bank branche(per 100,000 adults) of Honduras in 2007 to that in 2008?
Keep it short and to the point. 0.94. What is the ratio of the Bank branche(per 100,000 adults) of Mongolia in 2007 to that in 2008?
Offer a very short reply. 0.93. What is the ratio of the Bank branche(per 100,000 adults) of Caribbean small states in 2007 to that in 2009?
Provide a short and direct response. 1.01. What is the ratio of the Bank branche(per 100,000 adults) of Small states in 2007 to that in 2009?
Your response must be concise. 0.89. What is the ratio of the Bank branche(per 100,000 adults) in Mongolia in 2007 to that in 2009?
Provide a short and direct response. 0.98. What is the ratio of the Bank branche(per 100,000 adults) in Small states in 2007 to that in 2010?
Ensure brevity in your answer.  0.94. What is the ratio of the Bank branche(per 100,000 adults) in Honduras in 2007 to that in 2010?
Your answer should be compact. 1.11. What is the ratio of the Bank branche(per 100,000 adults) in Mongolia in 2007 to that in 2010?
Give a very brief answer. 0.97. What is the ratio of the Bank branche(per 100,000 adults) in Caribbean small states in 2008 to that in 2009?
Offer a very short reply. 1.02. What is the ratio of the Bank branche(per 100,000 adults) of Small states in 2008 to that in 2009?
Your answer should be compact. 1.05. What is the ratio of the Bank branche(per 100,000 adults) of Honduras in 2008 to that in 2009?
Ensure brevity in your answer.  1.04. What is the ratio of the Bank branche(per 100,000 adults) in Mongolia in 2008 to that in 2009?
Offer a terse response. 1.05. What is the ratio of the Bank branche(per 100,000 adults) of Small states in 2008 to that in 2010?
Offer a terse response. 1.1. What is the ratio of the Bank branche(per 100,000 adults) of Honduras in 2008 to that in 2010?
Give a very brief answer. 1.18. What is the ratio of the Bank branche(per 100,000 adults) in Mongolia in 2008 to that in 2010?
Make the answer very short. 1.05. What is the ratio of the Bank branche(per 100,000 adults) of Caribbean small states in 2009 to that in 2010?
Your answer should be very brief. 0.98. What is the ratio of the Bank branche(per 100,000 adults) in Small states in 2009 to that in 2010?
Offer a very short reply. 1.05. What is the ratio of the Bank branche(per 100,000 adults) of Honduras in 2009 to that in 2010?
Provide a short and direct response. 1.14. What is the ratio of the Bank branche(per 100,000 adults) of Mongolia in 2009 to that in 2010?
Give a very brief answer. 0.99. What is the difference between the highest and the second highest Bank branche(per 100,000 adults) in Caribbean small states?
Keep it short and to the point. 0.02. What is the difference between the highest and the second highest Bank branche(per 100,000 adults) in Small states?
Keep it short and to the point. 0.34. What is the difference between the highest and the second highest Bank branche(per 100,000 adults) of Honduras?
Keep it short and to the point. 0.95. What is the difference between the highest and the second highest Bank branche(per 100,000 adults) in Mongolia?
Make the answer very short. 2.54. What is the difference between the highest and the lowest Bank branche(per 100,000 adults) of Caribbean small states?
Your answer should be compact. 0.29. What is the difference between the highest and the lowest Bank branche(per 100,000 adults) of Small states?
Keep it short and to the point. 1.16. What is the difference between the highest and the lowest Bank branche(per 100,000 adults) of Honduras?
Provide a succinct answer. 8.11. What is the difference between the highest and the lowest Bank branche(per 100,000 adults) of Mongolia?
Provide a succinct answer. 17.24. 